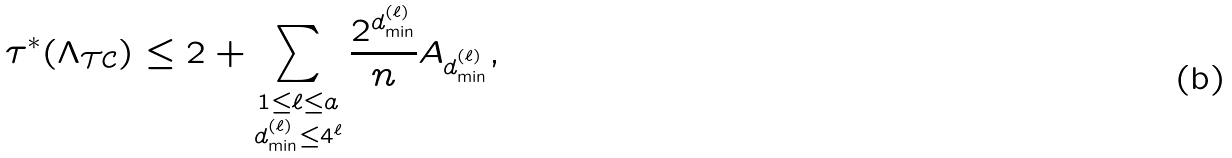Convert formula to latex. <formula><loc_0><loc_0><loc_500><loc_500>\tau ^ { \ast } ( \Lambda _ { \mathcal { T C } } ) \leq 2 + \sum _ { \substack { 1 \leq { \ell } \leq a \\ d _ { \min } ^ { ( \ell ) } \leq 4 ^ { \ell } } } \frac { 2 ^ { d _ { \min } ^ { ( \ell ) } } } { n } A _ { d _ { \min } ^ { ( \ell ) } } ,</formula> 